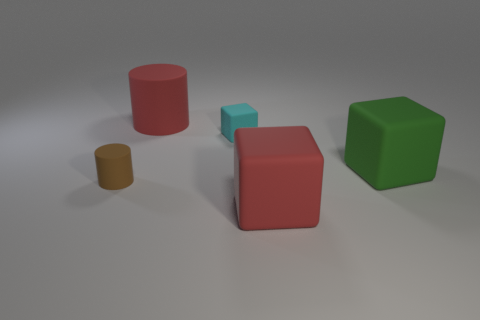What colors are the objects in the image? The objects present in the image include a large red cylinder, a large red cube, a small blue cube, and a large green cube. 